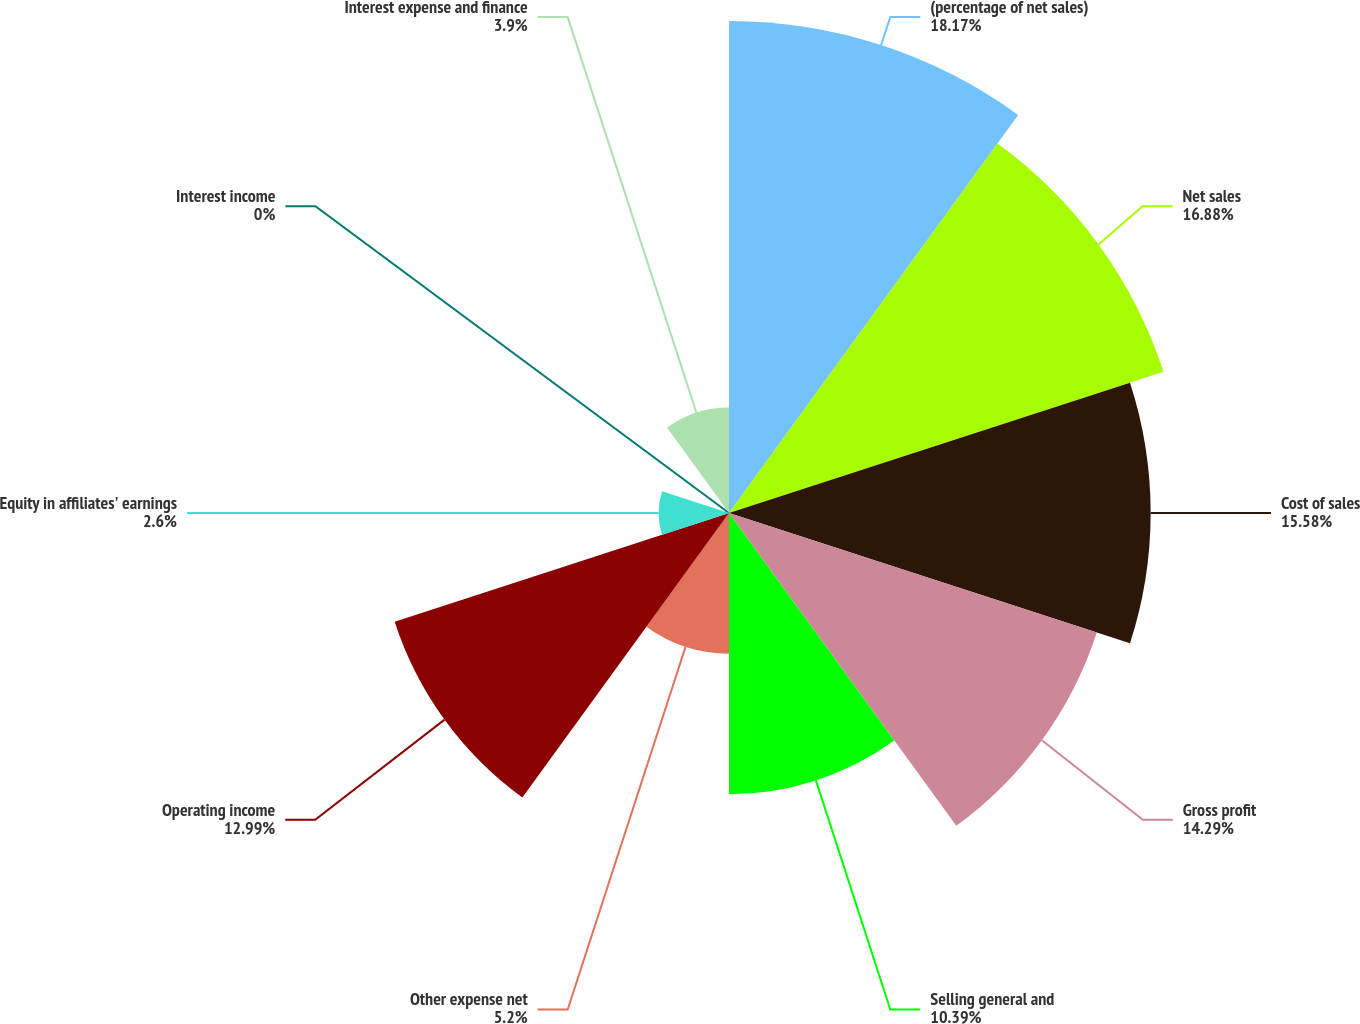Convert chart to OTSL. <chart><loc_0><loc_0><loc_500><loc_500><pie_chart><fcel>(percentage of net sales)<fcel>Net sales<fcel>Cost of sales<fcel>Gross profit<fcel>Selling general and<fcel>Other expense net<fcel>Operating income<fcel>Equity in affiliates' earnings<fcel>Interest income<fcel>Interest expense and finance<nl><fcel>18.18%<fcel>16.88%<fcel>15.58%<fcel>14.29%<fcel>10.39%<fcel>5.2%<fcel>12.99%<fcel>2.6%<fcel>0.0%<fcel>3.9%<nl></chart> 